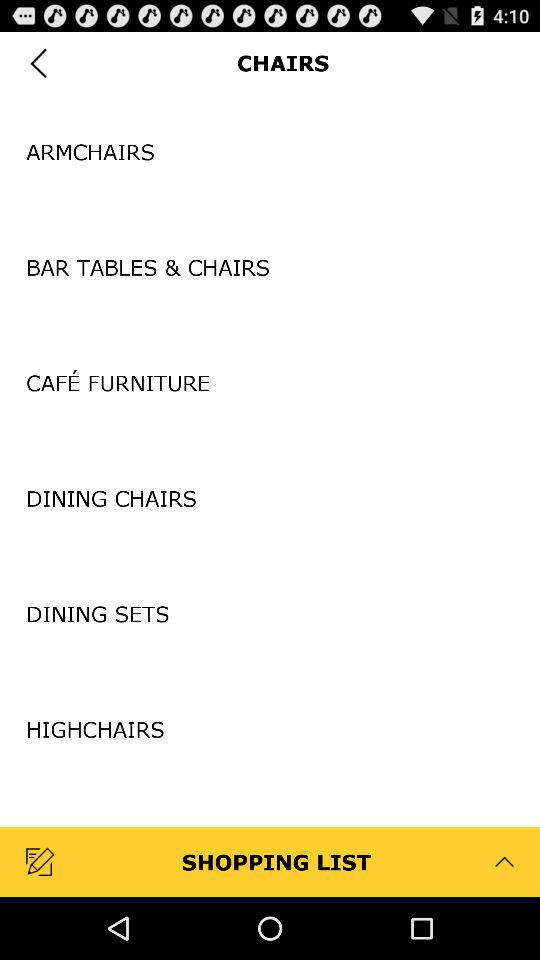How many items are there in the chairs category?
Answer the question using a single word or phrase. 6 